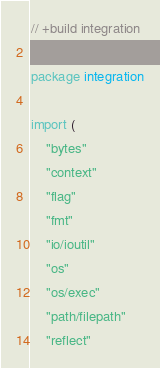Convert code to text. <code><loc_0><loc_0><loc_500><loc_500><_Go_>// +build integration

package integration

import (
	"bytes"
	"context"
	"flag"
	"fmt"
	"io/ioutil"
	"os"
	"os/exec"
	"path/filepath"
	"reflect"</code> 